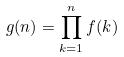Convert formula to latex. <formula><loc_0><loc_0><loc_500><loc_500>g ( n ) = \prod _ { k = 1 } ^ { n } f ( k )</formula> 